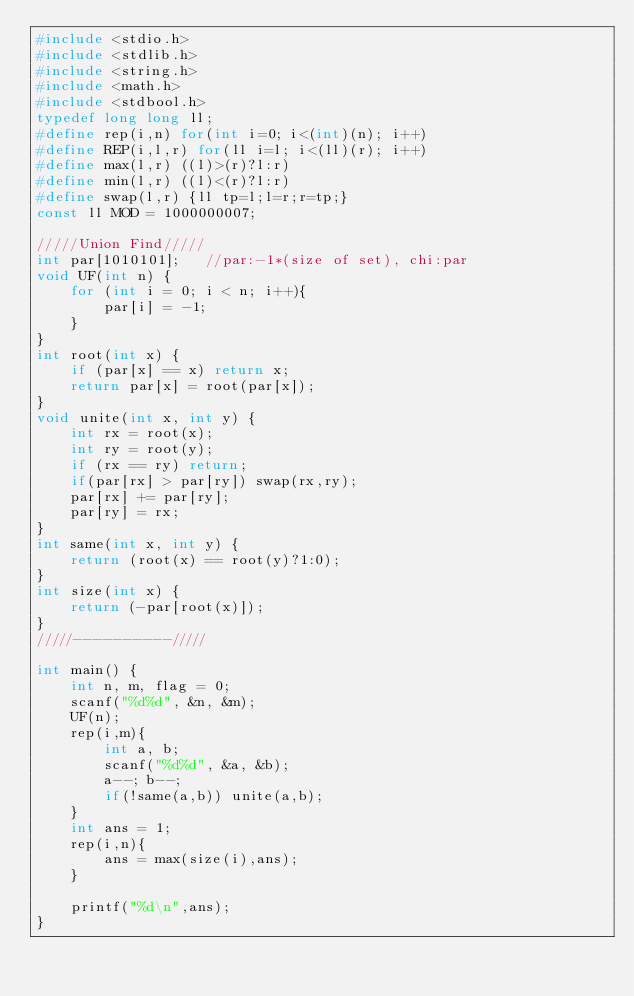<code> <loc_0><loc_0><loc_500><loc_500><_C_>#include <stdio.h>
#include <stdlib.h>
#include <string.h>
#include <math.h>
#include <stdbool.h>
typedef long long ll;
#define rep(i,n) for(int i=0; i<(int)(n); i++)
#define REP(i,l,r) for(ll i=l; i<(ll)(r); i++)
#define max(l,r) ((l)>(r)?l:r)
#define min(l,r) ((l)<(r)?l:r)
#define swap(l,r) {ll tp=l;l=r;r=tp;}
const ll MOD = 1000000007;

/////Union Find/////
int par[1010101];   //par:-1*(size of set), chi:par
void UF(int n) {
    for (int i = 0; i < n; i++){
        par[i] = -1;
    }
}
int root(int x) {
    if (par[x] == x) return x;
    return par[x] = root(par[x]);
}
void unite(int x, int y) {
    int rx = root(x);
    int ry = root(y);
    if (rx == ry) return;
    if(par[rx] > par[ry]) swap(rx,ry);
    par[rx] += par[ry];
    par[ry] = rx;
}
int same(int x, int y) {
    return (root(x) == root(y)?1:0);
}
int size(int x) {
    return (-par[root(x)]);
}
/////----------/////

int main() {
    int n, m, flag = 0;
    scanf("%d%d", &n, &m);
    UF(n);
    rep(i,m){
        int a, b;
        scanf("%d%d", &a, &b);
        a--; b--;
        if(!same(a,b)) unite(a,b);
    }
    int ans = 1;
    rep(i,n){
        ans = max(size(i),ans);
    }

    printf("%d\n",ans);
}</code> 